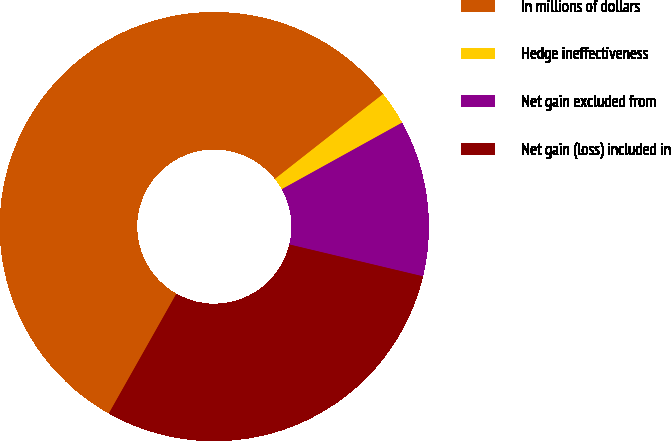Convert chart to OTSL. <chart><loc_0><loc_0><loc_500><loc_500><pie_chart><fcel>In millions of dollars<fcel>Hedge ineffectiveness<fcel>Net gain excluded from<fcel>Net gain (loss) included in<nl><fcel>56.23%<fcel>2.55%<fcel>11.77%<fcel>29.45%<nl></chart> 